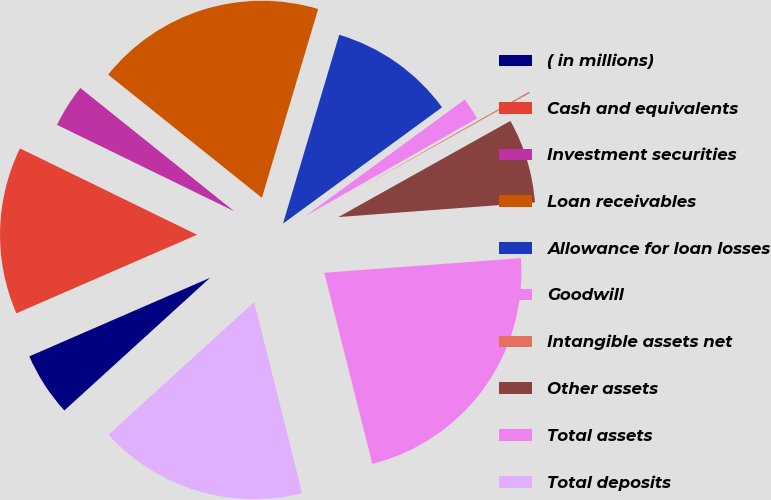Convert chart. <chart><loc_0><loc_0><loc_500><loc_500><pie_chart><fcel>( in millions)<fcel>Cash and equivalents<fcel>Investment securities<fcel>Loan receivables<fcel>Allowance for loan losses<fcel>Goodwill<fcel>Intangible assets net<fcel>Other assets<fcel>Total assets<fcel>Total deposits<nl><fcel>5.23%<fcel>13.75%<fcel>3.53%<fcel>18.86%<fcel>10.34%<fcel>1.82%<fcel>0.12%<fcel>6.93%<fcel>22.27%<fcel>17.16%<nl></chart> 